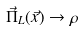<formula> <loc_0><loc_0><loc_500><loc_500>\vec { \Pi } _ { L } ( \vec { x } ) \rightarrow \rho</formula> 